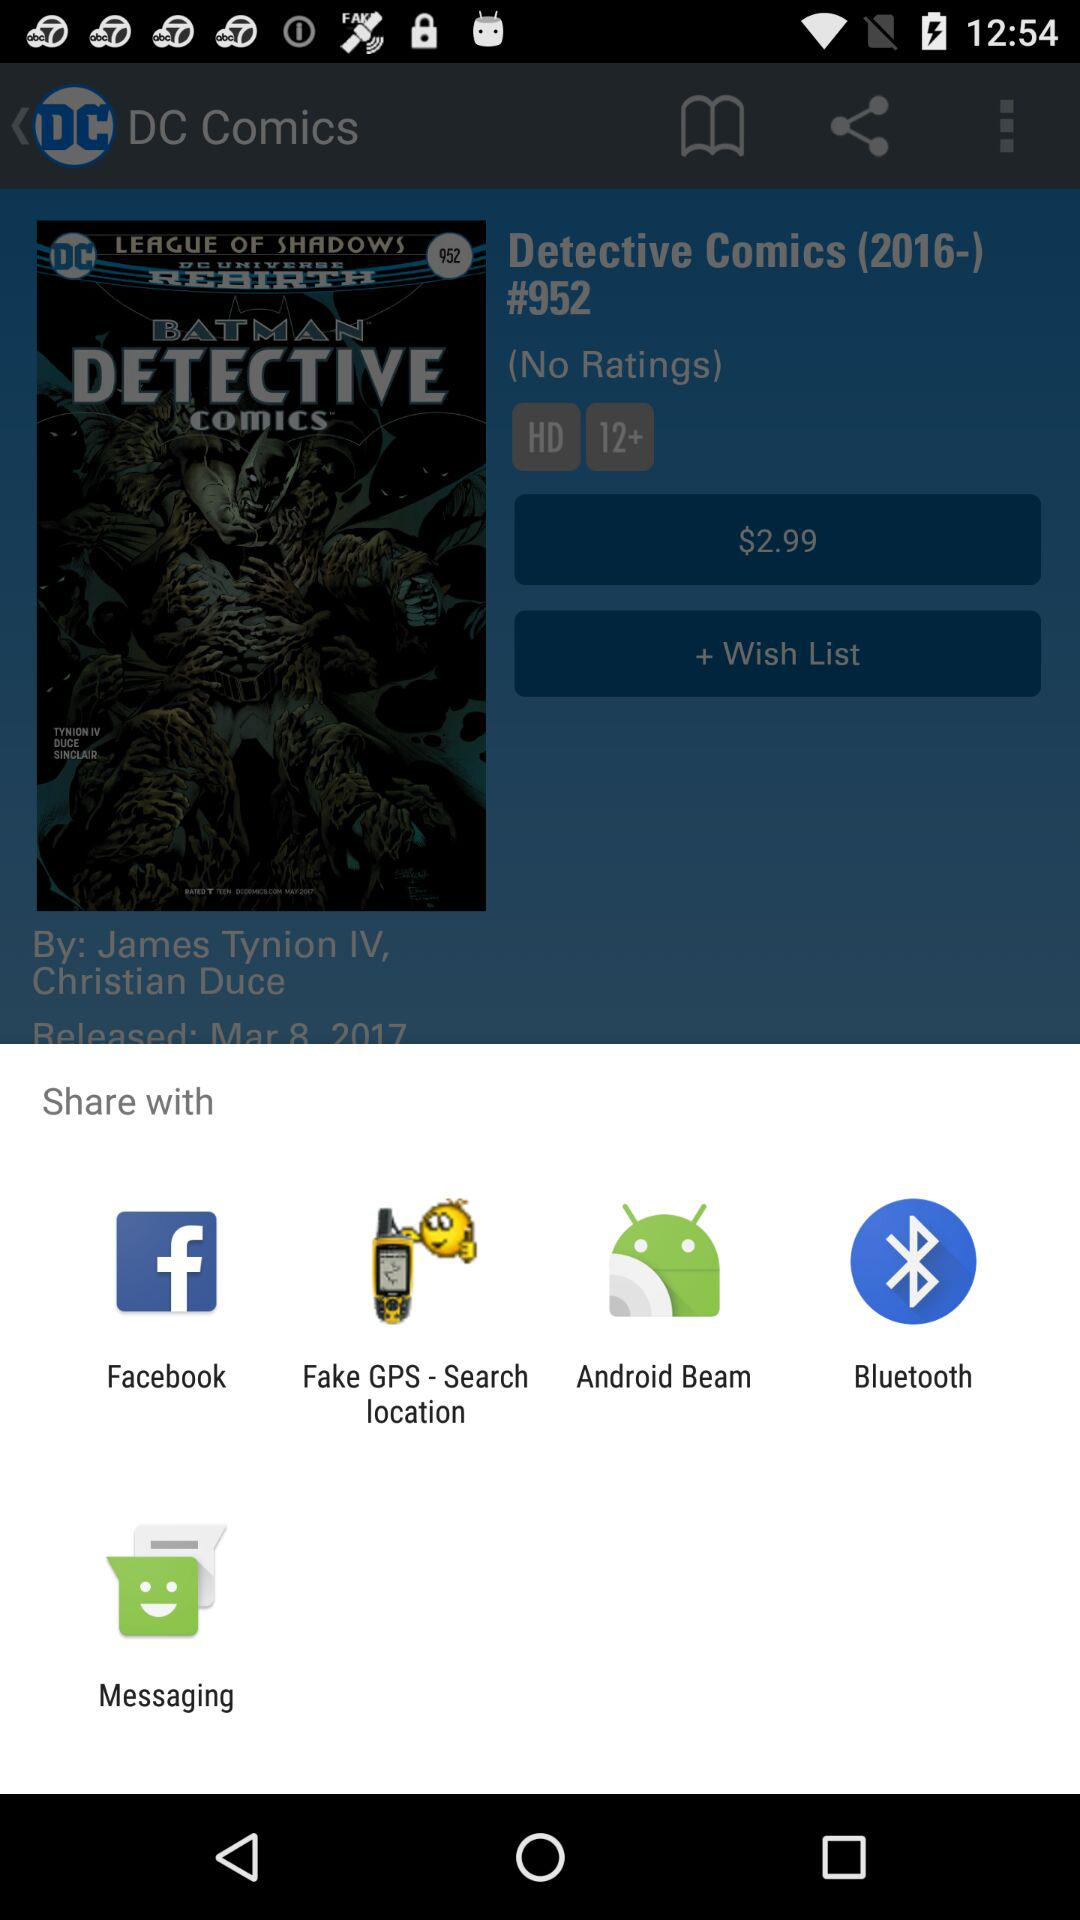What are the sharing options? The sharing options are "Facebook", "Fake GPS - Search location", "Android Beam", "Bluetooth" and "Messaging". 